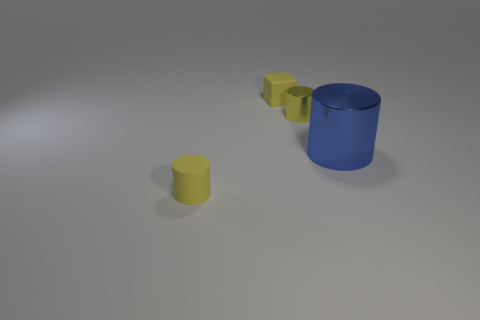Subtract all yellow cylinders. How many were subtracted if there are1yellow cylinders left? 1 Subtract all blue cubes. How many yellow cylinders are left? 2 Add 4 blue rubber balls. How many objects exist? 8 Subtract all small yellow matte cylinders. How many cylinders are left? 2 Subtract all blue cylinders. How many cylinders are left? 2 Subtract all tiny matte balls. Subtract all tiny yellow shiny things. How many objects are left? 3 Add 4 big blue cylinders. How many big blue cylinders are left? 5 Add 1 small yellow matte blocks. How many small yellow matte blocks exist? 2 Subtract 0 gray cylinders. How many objects are left? 4 Subtract all cylinders. How many objects are left? 1 